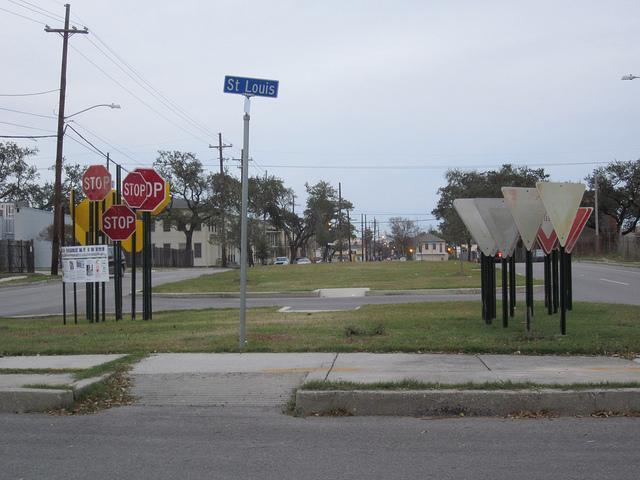How many stop signs?
Give a very brief answer. 4. How many orange barrels do you see?
Give a very brief answer. 0. How many rickshaws are there?
Give a very brief answer. 0. How many people are in this picture?
Give a very brief answer. 0. 